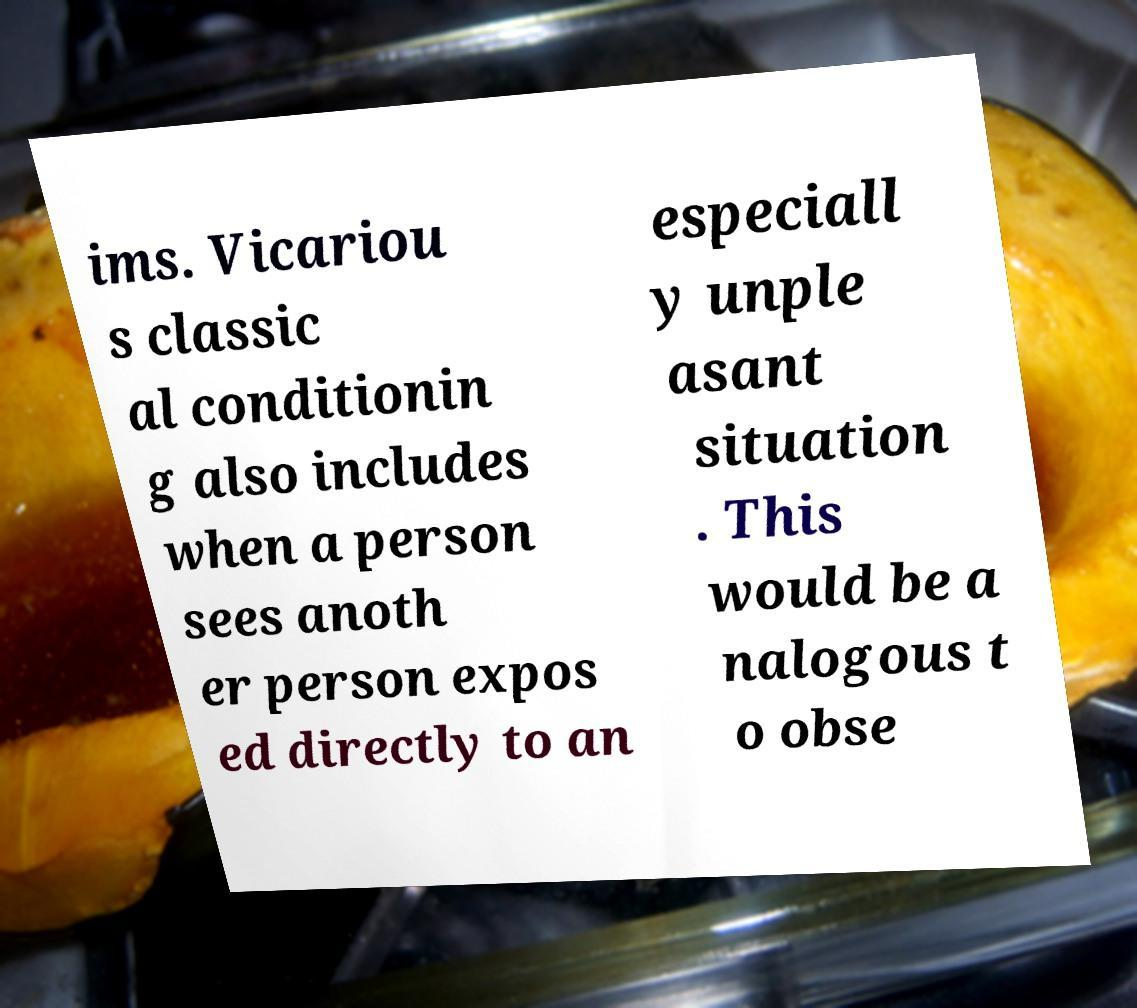Could you assist in decoding the text presented in this image and type it out clearly? ims. Vicariou s classic al conditionin g also includes when a person sees anoth er person expos ed directly to an especiall y unple asant situation . This would be a nalogous t o obse 